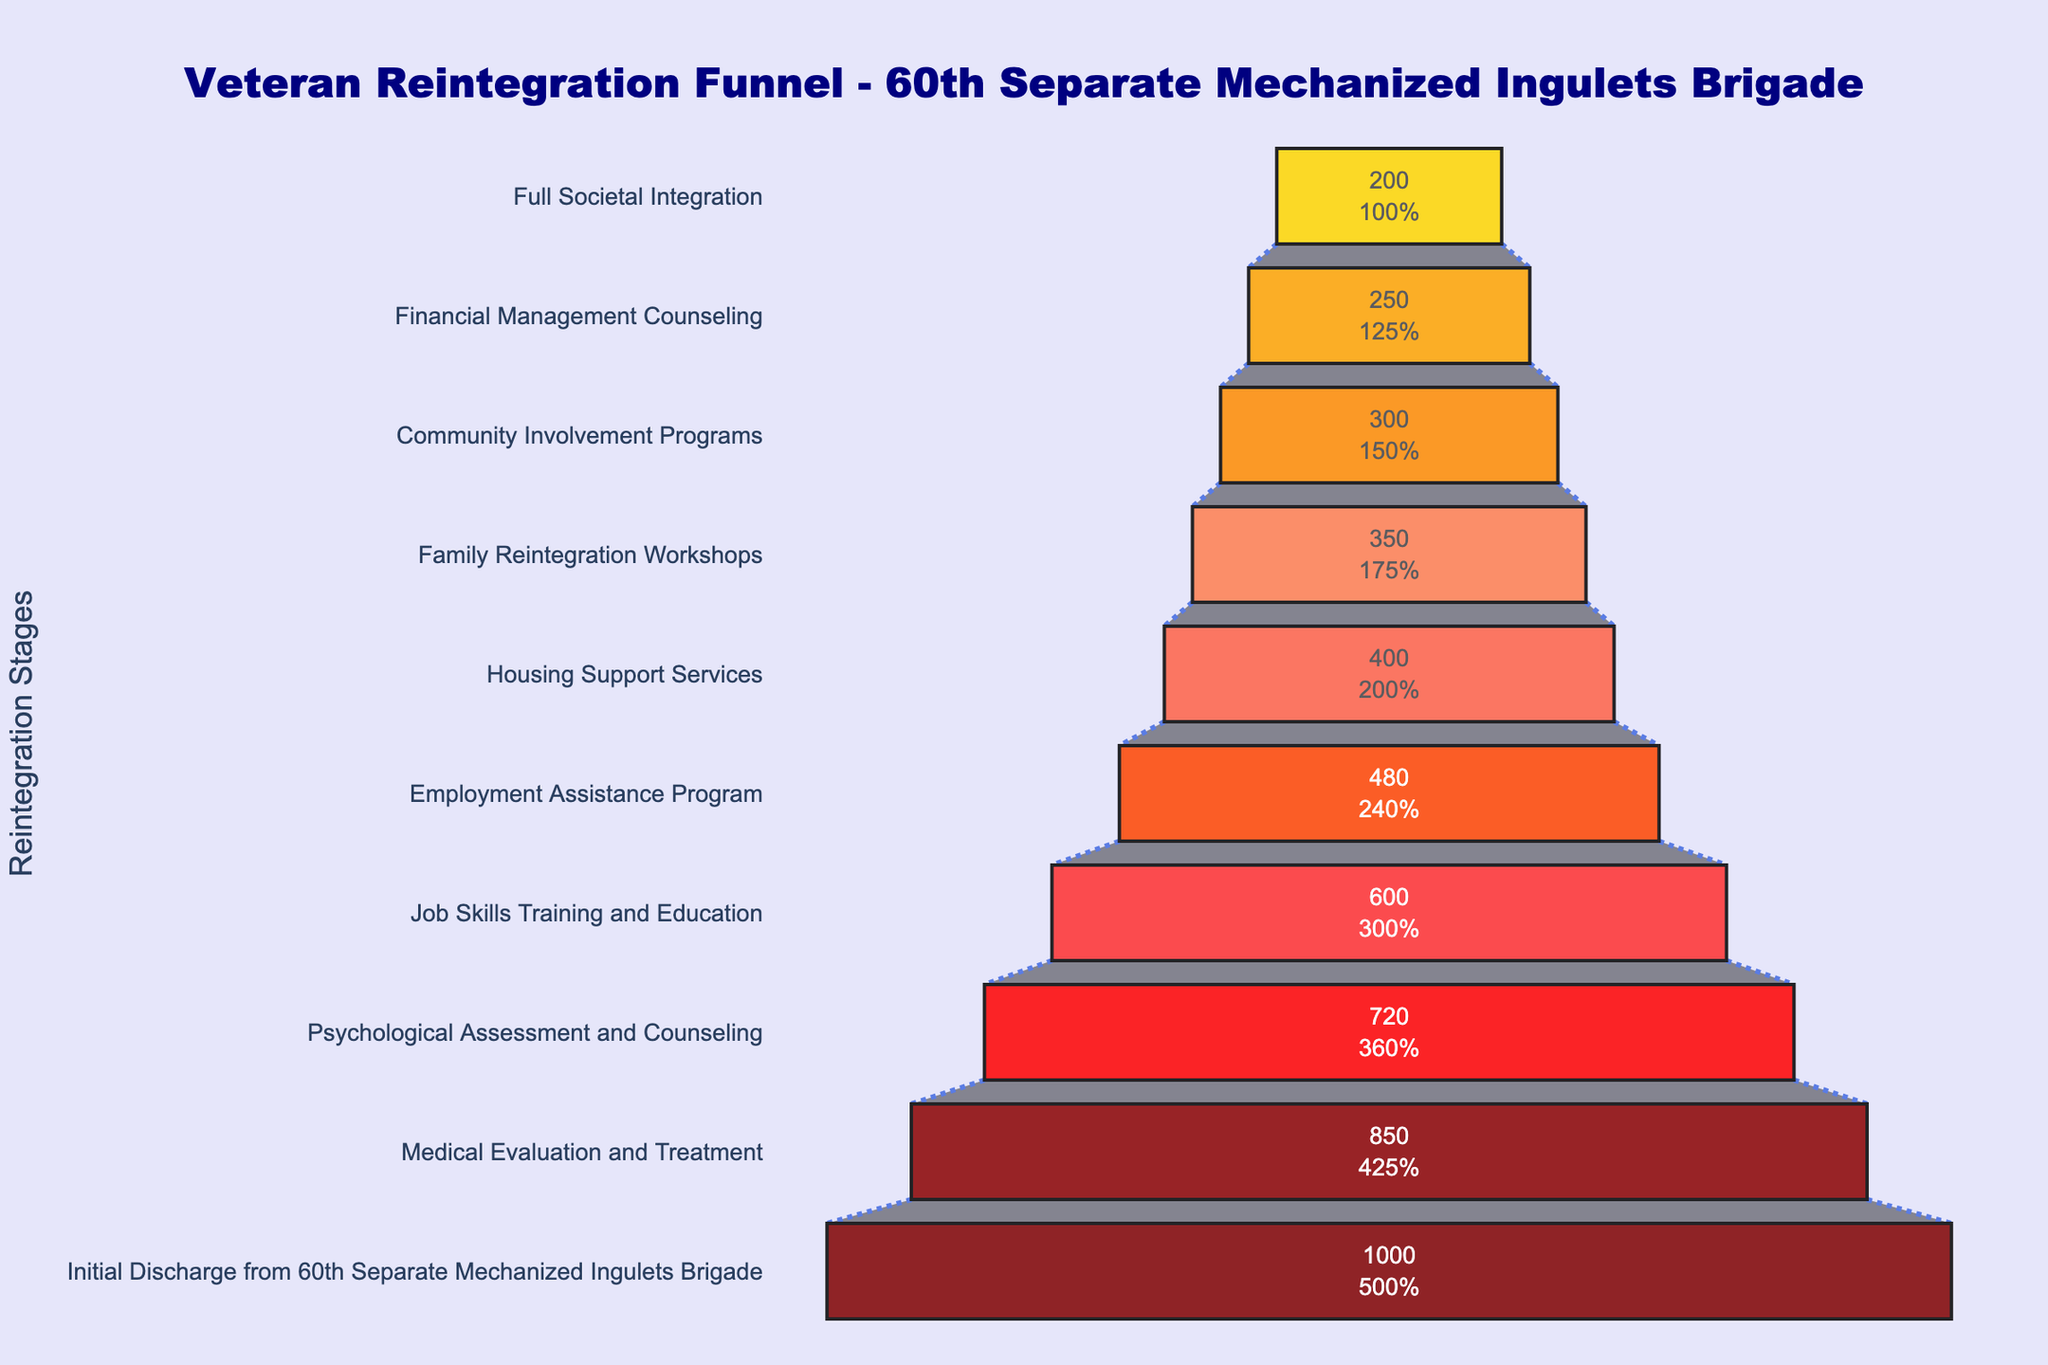How many veterans started in the initial discharge stage? The figure's first segment represents the initial discharge stage, which shows 1000 veterans.
Answer: 1000 What is the percentage of veterans that reached full societal integration compared to those initially discharged? The final segment for full societal integration shows 200 veterans. This is 20% of the initial 1000 veterans.
Answer: 20% Which stage saw the biggest drop in the number of veterans? By comparing the stages, the biggest drop is between Medical Evaluation and Treatment (850) and Psychological Assessment and Counseling (720). The drop is 130 veterans.
Answer: Medical Evaluation and Treatment to Psychological Assessment and Counseling Which stages have less than 400 veterans? Observing the stages with numbers below 400, they include Housing Support Services, Family Reintegration Workshops, Community Involvement Programs, Financial Management Counseling, and Full Societal Integration.
Answer: Housing Support Services, Family Reintegration Workshops, Community Involvement Programs, Financial Management Counseling, Full Societal Integration What is the difference in the number of veterans between the Job Skills Training and Education stage and the Employment Assistance Program stage? Job Skills Training and Education has 600 veterans and Employment Assistance Program has 480 veterans. The difference is 600 - 480, which equals 120.
Answer: 120 What is the total number of veterans remaining after the Psychological Assessment and Counseling stage? Summing up the veterans from this stage to the final stage: 720 for Psychological Assessment and Counseling, 600 for Job Skills Training and Education, 480 for Employment Assistance Program, 400 for Housing Support Services, 350 for Family Reintegration Workshops, 300 for Community Involvement Programs, 250 for Financial Management Counseling, and 200 for Full Societal Integration; the total is 3300.
Answer: 3300 What stage directly follows Job Skills Training and Education, and how many veterans are there in that stage? The stage following Job Skills Training and Education is the Employment Assistance Program, which has 480 veterans.
Answer: Employment Assistance Program, 480 What is the average number of veterans across all stages? The sum of veterans across all stages is 5100. There are 10 stages, so the average is 5100 / 10 = 510.
Answer: 510 What percentage of veterans receive Housing Support Services out of those who completed the Medical Evaluation and Treatment? Housing Support Services has 400 veterans and Medical Evaluation and Treatment has 850. The percentage is (400 / 850) × 100, which is about 47%.
Answer: 47% What is the difference in numbers between the Community Involvement Programs stage and the Full Societal Integration stage? Community Involvement Programs have 300 veterans, and Full Societal Integration has 200 veterans. The difference is 300 - 200, which equals 100.
Answer: 100 